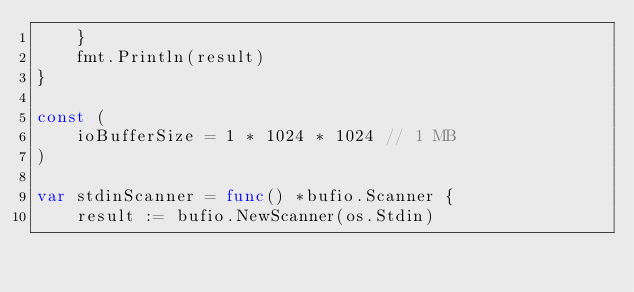<code> <loc_0><loc_0><loc_500><loc_500><_Go_>	}
	fmt.Println(result)
}

const (
	ioBufferSize = 1 * 1024 * 1024 // 1 MB
)

var stdinScanner = func() *bufio.Scanner {
	result := bufio.NewScanner(os.Stdin)</code> 